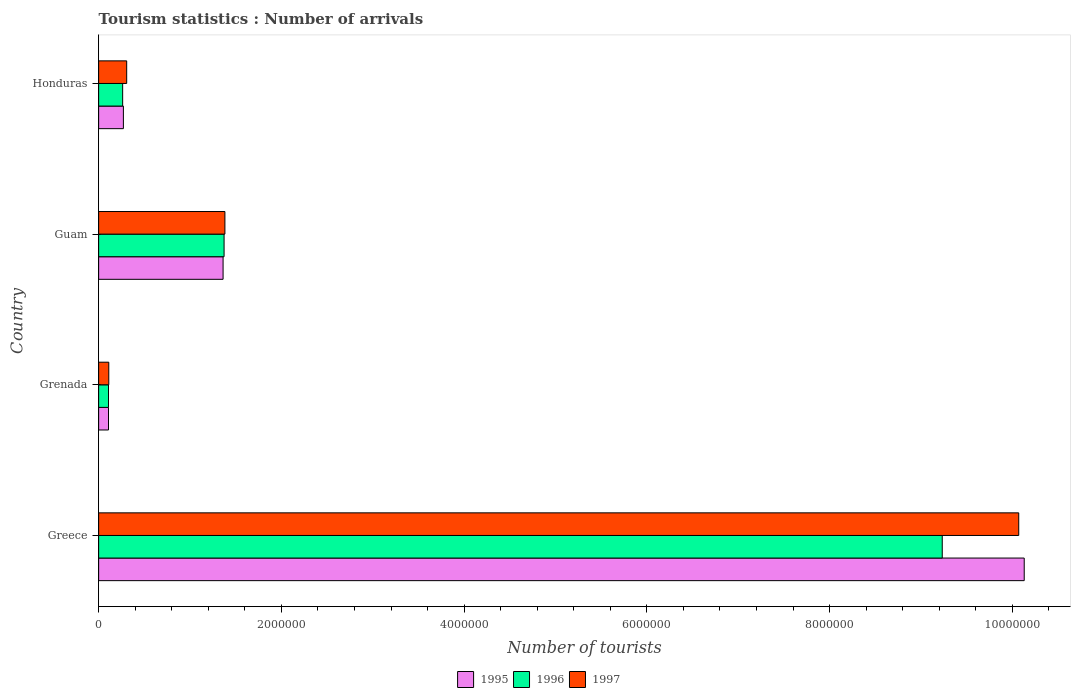How many groups of bars are there?
Give a very brief answer. 4. What is the label of the 1st group of bars from the top?
Your answer should be compact. Honduras. What is the number of tourist arrivals in 1996 in Guam?
Your response must be concise. 1.37e+06. Across all countries, what is the maximum number of tourist arrivals in 1997?
Give a very brief answer. 1.01e+07. Across all countries, what is the minimum number of tourist arrivals in 1997?
Give a very brief answer. 1.11e+05. In which country was the number of tourist arrivals in 1996 minimum?
Provide a short and direct response. Grenada. What is the total number of tourist arrivals in 1995 in the graph?
Provide a succinct answer. 1.19e+07. What is the difference between the number of tourist arrivals in 1995 in Grenada and that in Guam?
Keep it short and to the point. -1.25e+06. What is the difference between the number of tourist arrivals in 1996 in Honduras and the number of tourist arrivals in 1997 in Guam?
Provide a short and direct response. -1.12e+06. What is the average number of tourist arrivals in 1996 per country?
Your answer should be compact. 2.74e+06. What is the difference between the number of tourist arrivals in 1997 and number of tourist arrivals in 1996 in Greece?
Make the answer very short. 8.37e+05. In how many countries, is the number of tourist arrivals in 1996 greater than 8000000 ?
Give a very brief answer. 1. What is the ratio of the number of tourist arrivals in 1995 in Grenada to that in Guam?
Your answer should be very brief. 0.08. Is the difference between the number of tourist arrivals in 1997 in Greece and Guam greater than the difference between the number of tourist arrivals in 1996 in Greece and Guam?
Your answer should be very brief. Yes. What is the difference between the highest and the second highest number of tourist arrivals in 1995?
Ensure brevity in your answer.  8.77e+06. What is the difference between the highest and the lowest number of tourist arrivals in 1996?
Your answer should be very brief. 9.12e+06. Is the sum of the number of tourist arrivals in 1995 in Guam and Honduras greater than the maximum number of tourist arrivals in 1996 across all countries?
Make the answer very short. No. What does the 3rd bar from the bottom in Greece represents?
Ensure brevity in your answer.  1997. Is it the case that in every country, the sum of the number of tourist arrivals in 1997 and number of tourist arrivals in 1996 is greater than the number of tourist arrivals in 1995?
Make the answer very short. Yes. How many bars are there?
Provide a succinct answer. 12. Are all the bars in the graph horizontal?
Offer a very short reply. Yes. How many countries are there in the graph?
Provide a succinct answer. 4. Does the graph contain any zero values?
Your answer should be compact. No. How many legend labels are there?
Give a very brief answer. 3. What is the title of the graph?
Offer a very short reply. Tourism statistics : Number of arrivals. Does "1983" appear as one of the legend labels in the graph?
Your answer should be compact. No. What is the label or title of the X-axis?
Make the answer very short. Number of tourists. What is the Number of tourists of 1995 in Greece?
Keep it short and to the point. 1.01e+07. What is the Number of tourists of 1996 in Greece?
Make the answer very short. 9.23e+06. What is the Number of tourists of 1997 in Greece?
Offer a very short reply. 1.01e+07. What is the Number of tourists of 1995 in Grenada?
Provide a short and direct response. 1.08e+05. What is the Number of tourists of 1996 in Grenada?
Your response must be concise. 1.08e+05. What is the Number of tourists in 1997 in Grenada?
Provide a succinct answer. 1.11e+05. What is the Number of tourists in 1995 in Guam?
Your answer should be compact. 1.36e+06. What is the Number of tourists of 1996 in Guam?
Ensure brevity in your answer.  1.37e+06. What is the Number of tourists in 1997 in Guam?
Offer a very short reply. 1.38e+06. What is the Number of tourists of 1995 in Honduras?
Offer a terse response. 2.71e+05. What is the Number of tourists in 1996 in Honduras?
Make the answer very short. 2.63e+05. What is the Number of tourists of 1997 in Honduras?
Your response must be concise. 3.07e+05. Across all countries, what is the maximum Number of tourists in 1995?
Your answer should be very brief. 1.01e+07. Across all countries, what is the maximum Number of tourists in 1996?
Ensure brevity in your answer.  9.23e+06. Across all countries, what is the maximum Number of tourists in 1997?
Ensure brevity in your answer.  1.01e+07. Across all countries, what is the minimum Number of tourists of 1995?
Keep it short and to the point. 1.08e+05. Across all countries, what is the minimum Number of tourists of 1996?
Make the answer very short. 1.08e+05. Across all countries, what is the minimum Number of tourists in 1997?
Your answer should be very brief. 1.11e+05. What is the total Number of tourists in 1995 in the graph?
Offer a terse response. 1.19e+07. What is the total Number of tourists in 1996 in the graph?
Provide a short and direct response. 1.10e+07. What is the total Number of tourists of 1997 in the graph?
Offer a very short reply. 1.19e+07. What is the difference between the Number of tourists in 1995 in Greece and that in Grenada?
Offer a terse response. 1.00e+07. What is the difference between the Number of tourists of 1996 in Greece and that in Grenada?
Ensure brevity in your answer.  9.12e+06. What is the difference between the Number of tourists in 1997 in Greece and that in Grenada?
Offer a terse response. 9.96e+06. What is the difference between the Number of tourists of 1995 in Greece and that in Guam?
Give a very brief answer. 8.77e+06. What is the difference between the Number of tourists of 1996 in Greece and that in Guam?
Your answer should be very brief. 7.86e+06. What is the difference between the Number of tourists of 1997 in Greece and that in Guam?
Provide a short and direct response. 8.69e+06. What is the difference between the Number of tourists in 1995 in Greece and that in Honduras?
Give a very brief answer. 9.86e+06. What is the difference between the Number of tourists of 1996 in Greece and that in Honduras?
Offer a very short reply. 8.97e+06. What is the difference between the Number of tourists in 1997 in Greece and that in Honduras?
Offer a terse response. 9.76e+06. What is the difference between the Number of tourists of 1995 in Grenada and that in Guam?
Give a very brief answer. -1.25e+06. What is the difference between the Number of tourists of 1996 in Grenada and that in Guam?
Your response must be concise. -1.26e+06. What is the difference between the Number of tourists of 1997 in Grenada and that in Guam?
Provide a short and direct response. -1.27e+06. What is the difference between the Number of tourists in 1995 in Grenada and that in Honduras?
Ensure brevity in your answer.  -1.63e+05. What is the difference between the Number of tourists in 1996 in Grenada and that in Honduras?
Offer a terse response. -1.55e+05. What is the difference between the Number of tourists of 1997 in Grenada and that in Honduras?
Your answer should be very brief. -1.96e+05. What is the difference between the Number of tourists of 1995 in Guam and that in Honduras?
Give a very brief answer. 1.09e+06. What is the difference between the Number of tourists in 1996 in Guam and that in Honduras?
Ensure brevity in your answer.  1.11e+06. What is the difference between the Number of tourists of 1997 in Guam and that in Honduras?
Your response must be concise. 1.08e+06. What is the difference between the Number of tourists of 1995 in Greece and the Number of tourists of 1996 in Grenada?
Offer a terse response. 1.00e+07. What is the difference between the Number of tourists in 1995 in Greece and the Number of tourists in 1997 in Grenada?
Keep it short and to the point. 1.00e+07. What is the difference between the Number of tourists of 1996 in Greece and the Number of tourists of 1997 in Grenada?
Provide a succinct answer. 9.12e+06. What is the difference between the Number of tourists in 1995 in Greece and the Number of tourists in 1996 in Guam?
Ensure brevity in your answer.  8.76e+06. What is the difference between the Number of tourists of 1995 in Greece and the Number of tourists of 1997 in Guam?
Make the answer very short. 8.75e+06. What is the difference between the Number of tourists of 1996 in Greece and the Number of tourists of 1997 in Guam?
Make the answer very short. 7.85e+06. What is the difference between the Number of tourists in 1995 in Greece and the Number of tourists in 1996 in Honduras?
Your answer should be compact. 9.87e+06. What is the difference between the Number of tourists of 1995 in Greece and the Number of tourists of 1997 in Honduras?
Offer a very short reply. 9.82e+06. What is the difference between the Number of tourists of 1996 in Greece and the Number of tourists of 1997 in Honduras?
Offer a terse response. 8.93e+06. What is the difference between the Number of tourists in 1995 in Grenada and the Number of tourists in 1996 in Guam?
Your answer should be compact. -1.26e+06. What is the difference between the Number of tourists in 1995 in Grenada and the Number of tourists in 1997 in Guam?
Your answer should be very brief. -1.27e+06. What is the difference between the Number of tourists of 1996 in Grenada and the Number of tourists of 1997 in Guam?
Keep it short and to the point. -1.27e+06. What is the difference between the Number of tourists of 1995 in Grenada and the Number of tourists of 1996 in Honduras?
Your response must be concise. -1.55e+05. What is the difference between the Number of tourists of 1995 in Grenada and the Number of tourists of 1997 in Honduras?
Your answer should be very brief. -1.99e+05. What is the difference between the Number of tourists of 1996 in Grenada and the Number of tourists of 1997 in Honduras?
Your response must be concise. -1.99e+05. What is the difference between the Number of tourists in 1995 in Guam and the Number of tourists in 1996 in Honduras?
Your answer should be compact. 1.10e+06. What is the difference between the Number of tourists of 1995 in Guam and the Number of tourists of 1997 in Honduras?
Provide a succinct answer. 1.06e+06. What is the difference between the Number of tourists of 1996 in Guam and the Number of tourists of 1997 in Honduras?
Give a very brief answer. 1.07e+06. What is the average Number of tourists of 1995 per country?
Offer a very short reply. 2.97e+06. What is the average Number of tourists of 1996 per country?
Your answer should be compact. 2.74e+06. What is the average Number of tourists of 1997 per country?
Offer a very short reply. 2.97e+06. What is the difference between the Number of tourists in 1995 and Number of tourists in 1996 in Greece?
Your answer should be very brief. 8.97e+05. What is the difference between the Number of tourists of 1996 and Number of tourists of 1997 in Greece?
Keep it short and to the point. -8.37e+05. What is the difference between the Number of tourists in 1995 and Number of tourists in 1997 in Grenada?
Offer a very short reply. -3000. What is the difference between the Number of tourists in 1996 and Number of tourists in 1997 in Grenada?
Keep it short and to the point. -3000. What is the difference between the Number of tourists in 1995 and Number of tourists in 1996 in Guam?
Make the answer very short. -1.10e+04. What is the difference between the Number of tourists of 1996 and Number of tourists of 1997 in Guam?
Your response must be concise. -9000. What is the difference between the Number of tourists of 1995 and Number of tourists of 1996 in Honduras?
Make the answer very short. 8000. What is the difference between the Number of tourists in 1995 and Number of tourists in 1997 in Honduras?
Give a very brief answer. -3.60e+04. What is the difference between the Number of tourists in 1996 and Number of tourists in 1997 in Honduras?
Provide a succinct answer. -4.40e+04. What is the ratio of the Number of tourists in 1995 in Greece to that in Grenada?
Provide a succinct answer. 93.8. What is the ratio of the Number of tourists of 1996 in Greece to that in Grenada?
Offer a terse response. 85.49. What is the ratio of the Number of tourists of 1997 in Greece to that in Grenada?
Provide a short and direct response. 90.72. What is the ratio of the Number of tourists in 1995 in Greece to that in Guam?
Give a very brief answer. 7.44. What is the ratio of the Number of tourists in 1996 in Greece to that in Guam?
Give a very brief answer. 6.72. What is the ratio of the Number of tourists in 1997 in Greece to that in Guam?
Keep it short and to the point. 7.29. What is the ratio of the Number of tourists in 1995 in Greece to that in Honduras?
Ensure brevity in your answer.  37.38. What is the ratio of the Number of tourists of 1996 in Greece to that in Honduras?
Your response must be concise. 35.11. What is the ratio of the Number of tourists of 1997 in Greece to that in Honduras?
Keep it short and to the point. 32.8. What is the ratio of the Number of tourists of 1995 in Grenada to that in Guam?
Keep it short and to the point. 0.08. What is the ratio of the Number of tourists in 1996 in Grenada to that in Guam?
Provide a succinct answer. 0.08. What is the ratio of the Number of tourists of 1997 in Grenada to that in Guam?
Your answer should be very brief. 0.08. What is the ratio of the Number of tourists in 1995 in Grenada to that in Honduras?
Provide a short and direct response. 0.4. What is the ratio of the Number of tourists of 1996 in Grenada to that in Honduras?
Keep it short and to the point. 0.41. What is the ratio of the Number of tourists of 1997 in Grenada to that in Honduras?
Ensure brevity in your answer.  0.36. What is the ratio of the Number of tourists of 1995 in Guam to that in Honduras?
Provide a short and direct response. 5.03. What is the ratio of the Number of tourists in 1996 in Guam to that in Honduras?
Give a very brief answer. 5.22. What is the ratio of the Number of tourists in 1997 in Guam to that in Honduras?
Provide a short and direct response. 4.5. What is the difference between the highest and the second highest Number of tourists in 1995?
Provide a short and direct response. 8.77e+06. What is the difference between the highest and the second highest Number of tourists of 1996?
Keep it short and to the point. 7.86e+06. What is the difference between the highest and the second highest Number of tourists in 1997?
Provide a short and direct response. 8.69e+06. What is the difference between the highest and the lowest Number of tourists of 1995?
Offer a terse response. 1.00e+07. What is the difference between the highest and the lowest Number of tourists of 1996?
Your answer should be very brief. 9.12e+06. What is the difference between the highest and the lowest Number of tourists of 1997?
Offer a very short reply. 9.96e+06. 